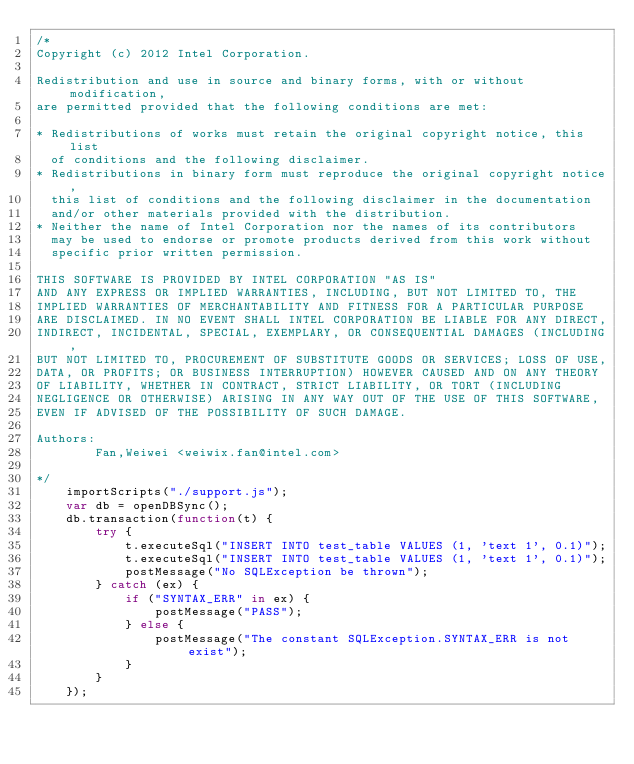<code> <loc_0><loc_0><loc_500><loc_500><_JavaScript_>/*
Copyright (c) 2012 Intel Corporation.

Redistribution and use in source and binary forms, with or without modification,
are permitted provided that the following conditions are met:

* Redistributions of works must retain the original copyright notice, this list
  of conditions and the following disclaimer.
* Redistributions in binary form must reproduce the original copyright notice,
  this list of conditions and the following disclaimer in the documentation
  and/or other materials provided with the distribution.
* Neither the name of Intel Corporation nor the names of its contributors
  may be used to endorse or promote products derived from this work without
  specific prior written permission.

THIS SOFTWARE IS PROVIDED BY INTEL CORPORATION "AS IS"
AND ANY EXPRESS OR IMPLIED WARRANTIES, INCLUDING, BUT NOT LIMITED TO, THE
IMPLIED WARRANTIES OF MERCHANTABILITY AND FITNESS FOR A PARTICULAR PURPOSE
ARE DISCLAIMED. IN NO EVENT SHALL INTEL CORPORATION BE LIABLE FOR ANY DIRECT,
INDIRECT, INCIDENTAL, SPECIAL, EXEMPLARY, OR CONSEQUENTIAL DAMAGES (INCLUDING,
BUT NOT LIMITED TO, PROCUREMENT OF SUBSTITUTE GOODS OR SERVICES; LOSS OF USE,
DATA, OR PROFITS; OR BUSINESS INTERRUPTION) HOWEVER CAUSED AND ON ANY THEORY
OF LIABILITY, WHETHER IN CONTRACT, STRICT LIABILITY, OR TORT (INCLUDING
NEGLIGENCE OR OTHERWISE) ARISING IN ANY WAY OUT OF THE USE OF THIS SOFTWARE,
EVEN IF ADVISED OF THE POSSIBILITY OF SUCH DAMAGE.

Authors:
        Fan,Weiwei <weiwix.fan@intel.com>

*/
    importScripts("./support.js");
    var db = openDBSync();
    db.transaction(function(t) {
        try {
            t.executeSql("INSERT INTO test_table VALUES (1, 'text 1', 0.1)");
            t.executeSql("INSERT INTO test_table VALUES (1, 'text 1', 0.1)");
            postMessage("No SQLException be thrown");
        } catch (ex) {
            if ("SYNTAX_ERR" in ex) {
                postMessage("PASS");
            } else {
                postMessage("The constant SQLException.SYNTAX_ERR is not exist");
            }
        }
    });
</code> 